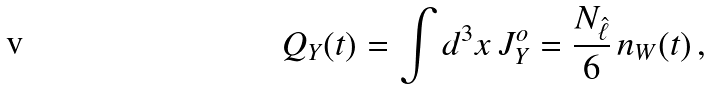<formula> <loc_0><loc_0><loc_500><loc_500>Q _ { Y } ( t ) = \int d ^ { 3 } x \, J ^ { o } _ { Y } = \frac { N _ { \hat { \ell } } } { 6 } \, n _ { W } ( t ) \, ,</formula> 